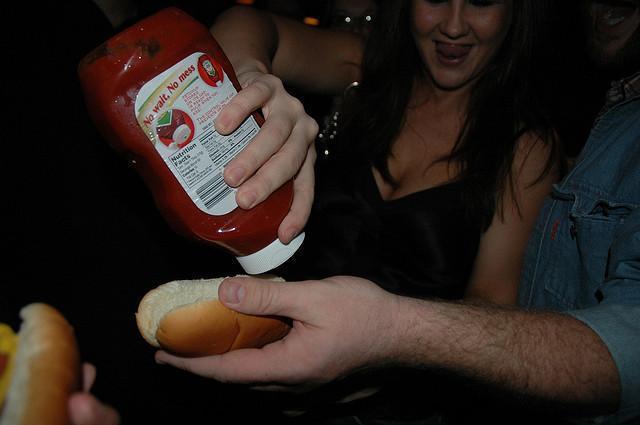How many fingers are visible in this picture?
Give a very brief answer. 7. How many people are there?
Give a very brief answer. 2. How many hot dogs can you see?
Give a very brief answer. 2. How many pizzas are on the stove?
Give a very brief answer. 0. 